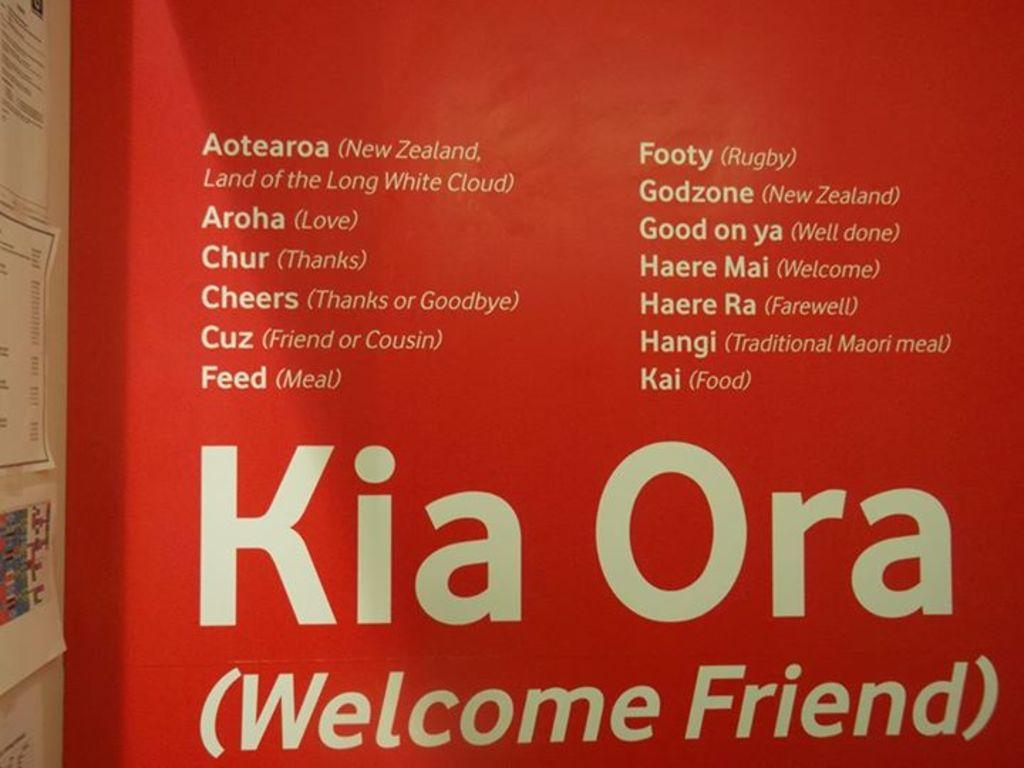What does kia ora mean?
Ensure brevity in your answer.  Welcome friend. What does aroha mean?
Keep it short and to the point. Love. 